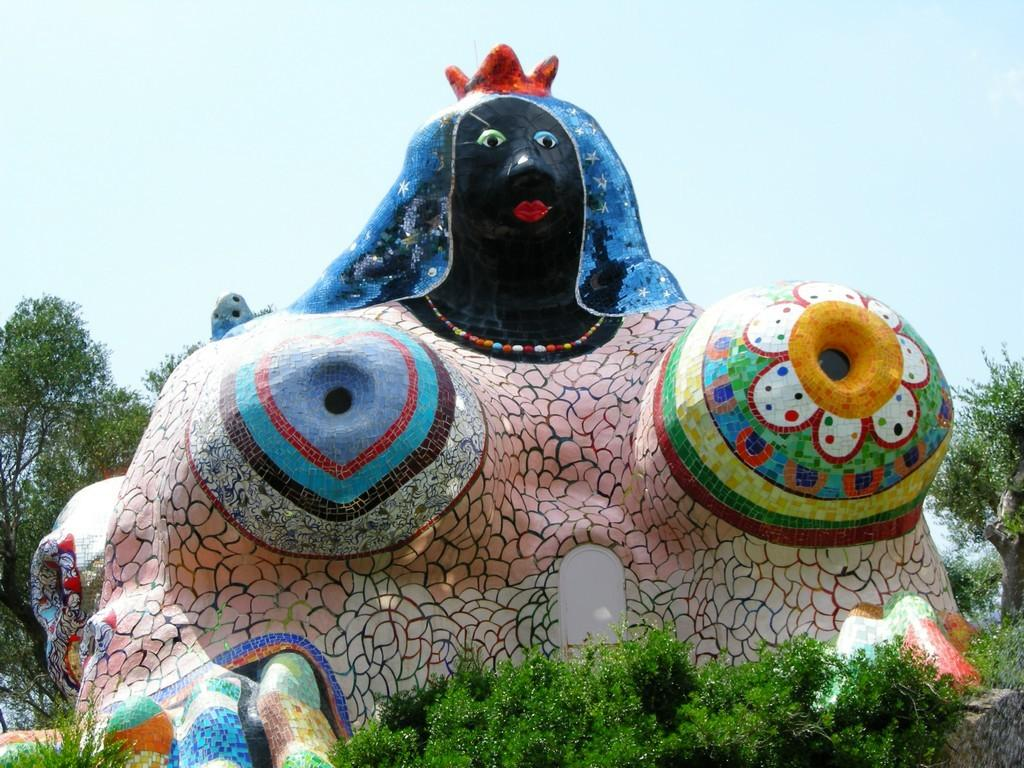What is the main subject of the image? There is a sculpture at the center of the image. What can be seen around the sculpture? There are trees surrounding the sculpture. What is visible in the background of the image? The sky is visible in the background of the image. What type of poison is being used to protect the sculpture from insects in the image? There is no mention of poison or insects in the image; it features a sculpture surrounded by trees with the sky visible in the background. 